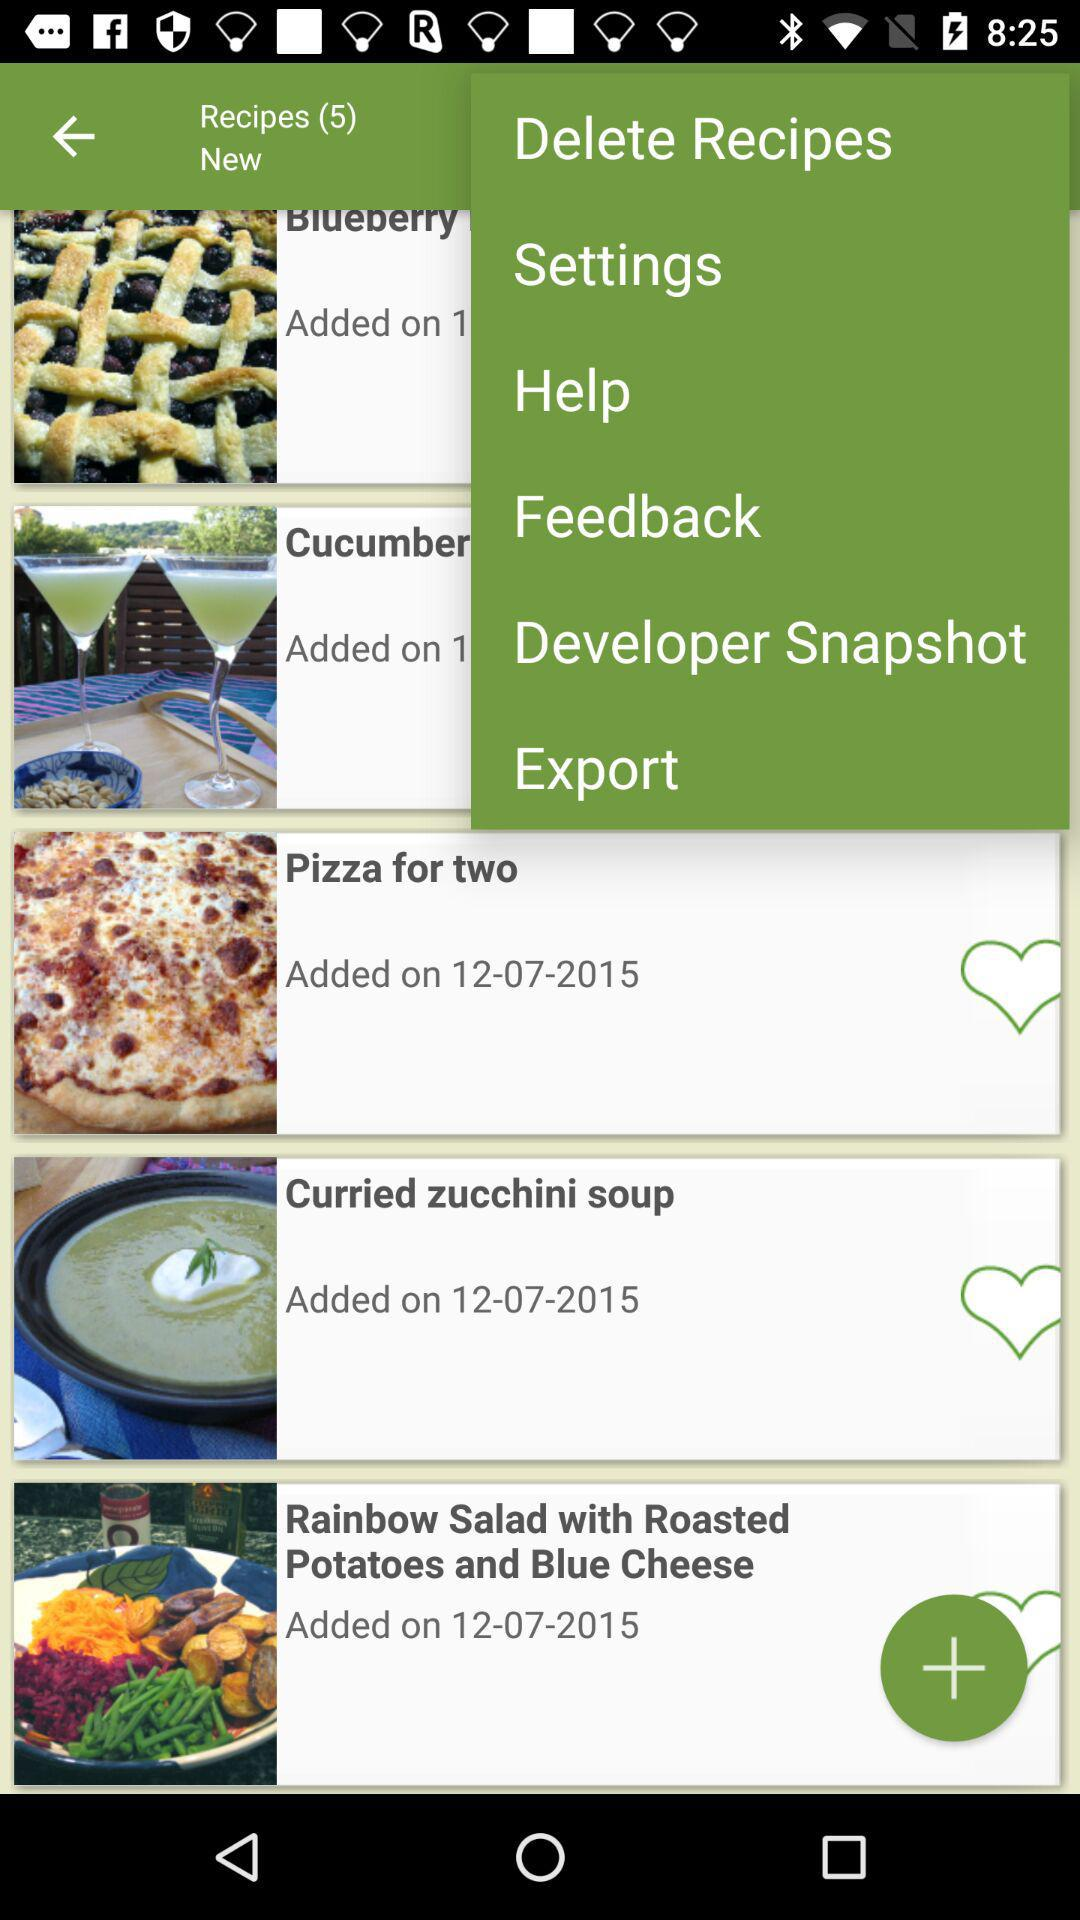When was the recipe "Curried zucchini soup" added? The recipe "Curried zucchini soup" was added on December 7, 2015. 